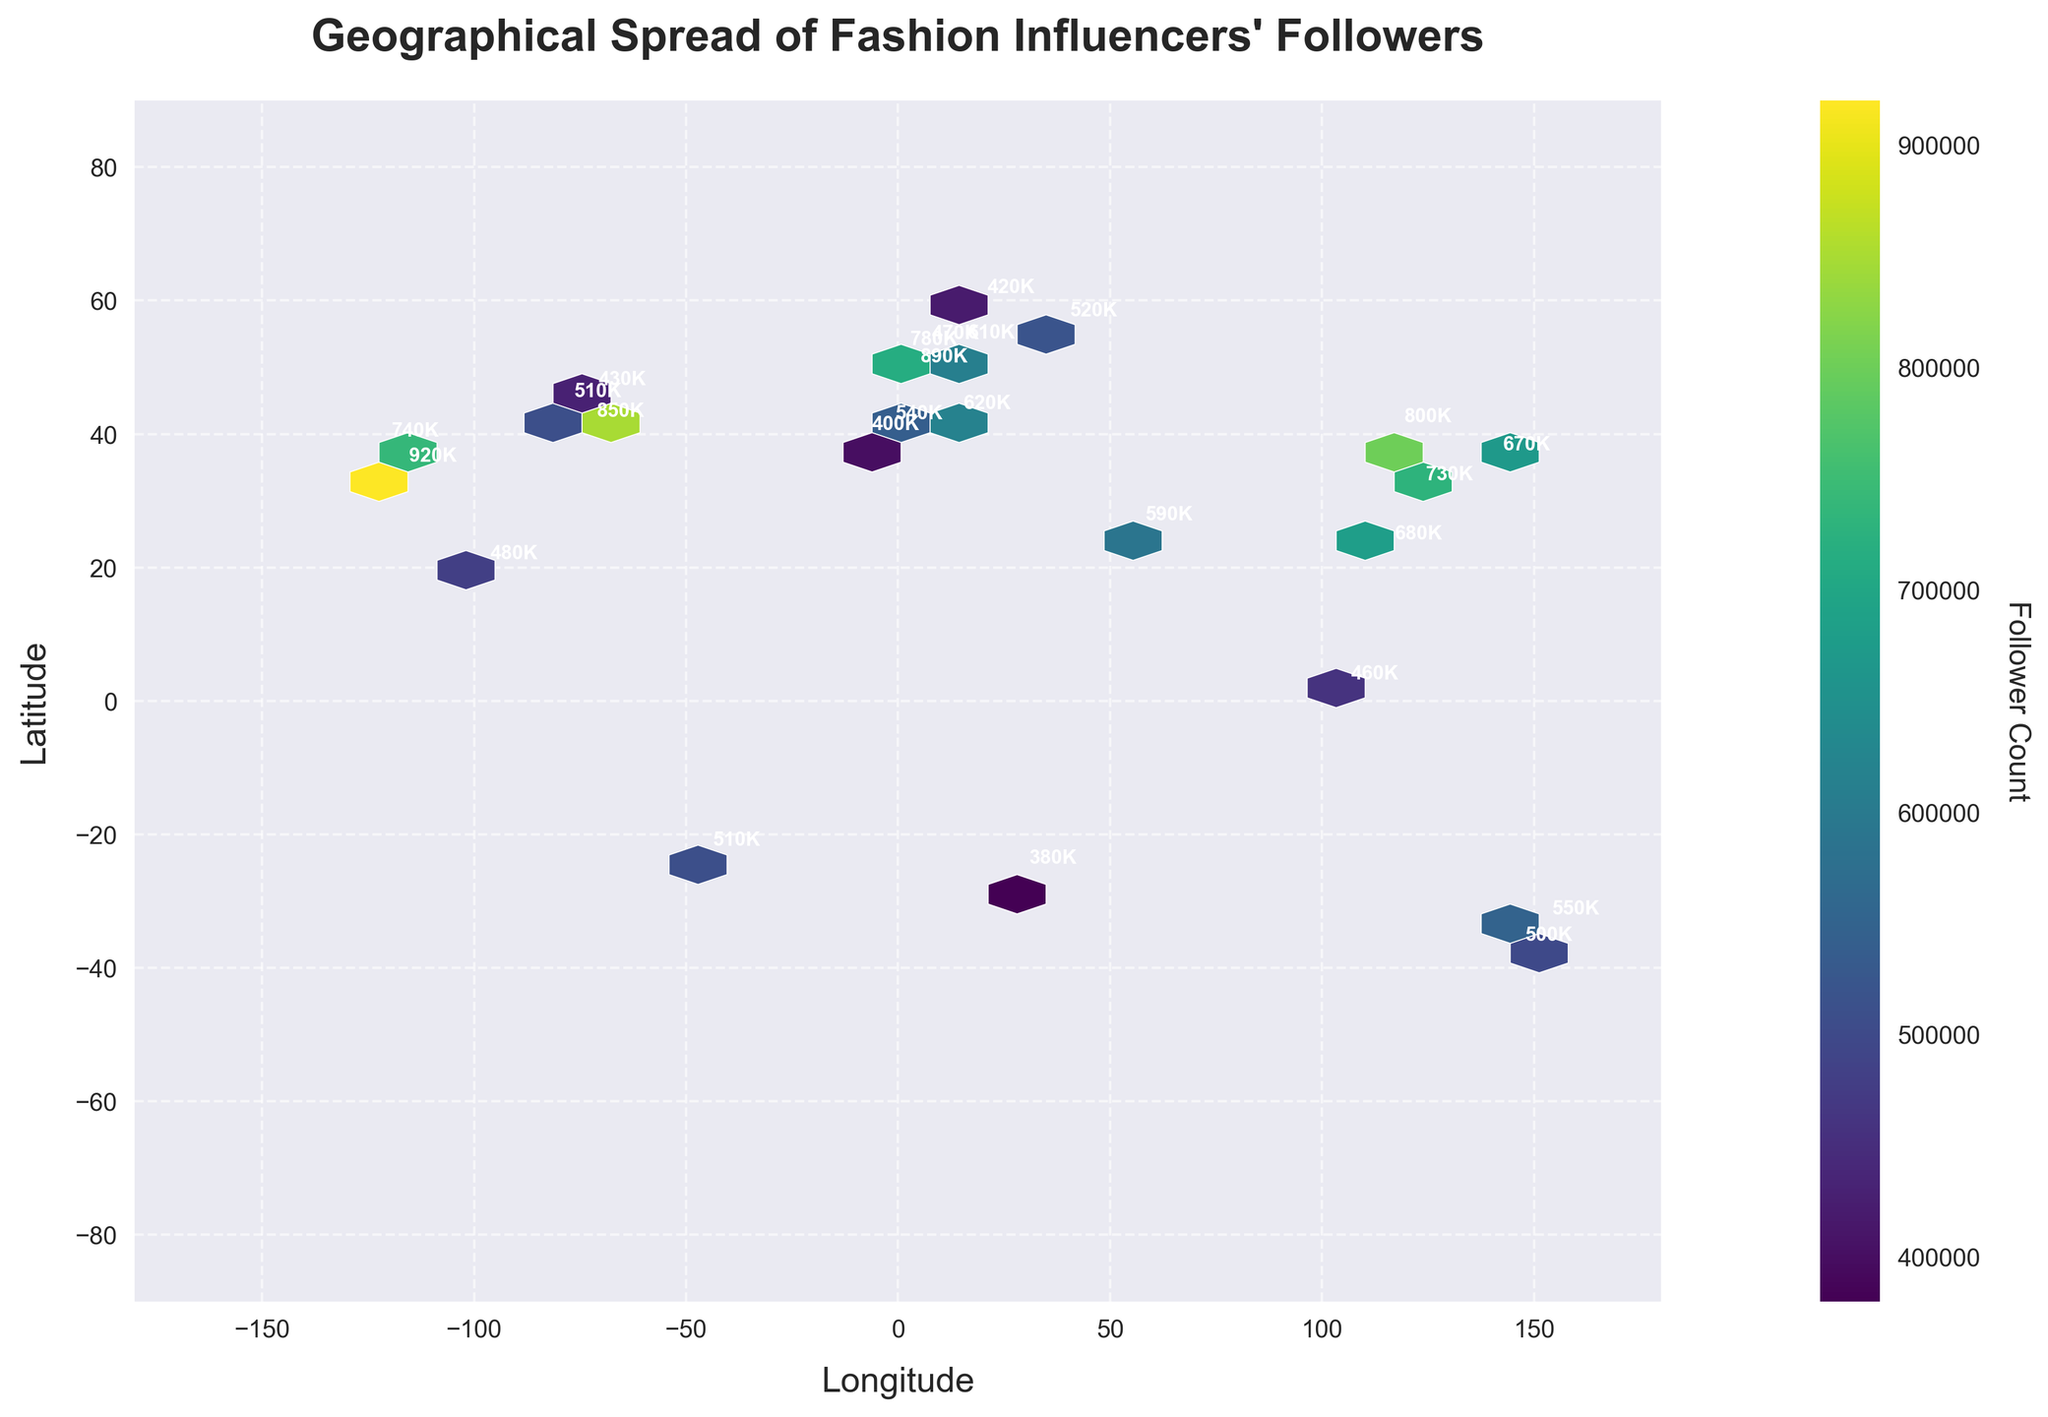What's the title of the plot? The title of the plot is displayed at the top of the figure. It is usually meant to provide a brief description of what the plot represents.
Answer: Geographical Spread of Fashion Influencers' Followers What do the colors in the plot represent? In a hexbin plot, colors are used to indicate the density or count of data points within each hexagonal bin. Generally, a color bar or legend is provided alongside the plot to show the range of values.
Answer: Follower Count How many major cities are represented in the plot? By counting the number of labeled points (annotations) on the plot, one can determine the number of major cities included. Each city is labeled with its follower count in thousands (K).
Answer: 24 Which city has the highest number of followers? By looking at the annotations next to each city, one can identify the city with the highest follower count. The city with the highest number will be prominently labeled.
Answer: Los Angeles (920K) Is there a city in Asia with more than 800,000 followers? By examining the annotations of the cities located in Asia, one can identify if any of them have a follower count exceeding 800,000.
Answer: Beijing (800K) What is the range of the latitude in the plot? The y-axis of the plot represents latitude, ranging from the minimum to the maximum value. Observing the axis ticks and labels can provide this range.
Answer: -90 to 90 Which city in Europe has the highest number of followers? By examining the cities plotted in Europe and their respective annotations, one can identify which European city has the highest follower count.
Answer: Paris (890K) Compare the number of followers between New York and Tokyo. Which city has more followers and by how much? The annotations next to New York and Tokyo indicate their follower counts. By subtracting the follower count of Tokyo from that of New York, one can determine the difference.
Answer: New York has 180K more followers than Tokyo What is the median follower count among all cities? To find the median, list the follower counts of all cities in ascending order and identify the middle value. If there is an even number of cities, the median is the average of the two middle numbers.
Answer: 610K Why do some hexagons have different shades in the hexbin plot? Different shades in the hexbin plot represent variations in density or count of followers within each hexagonal bin. Darker shades usually indicate higher densities of data points, as depicted by the color bar.
Answer: Density of data points 